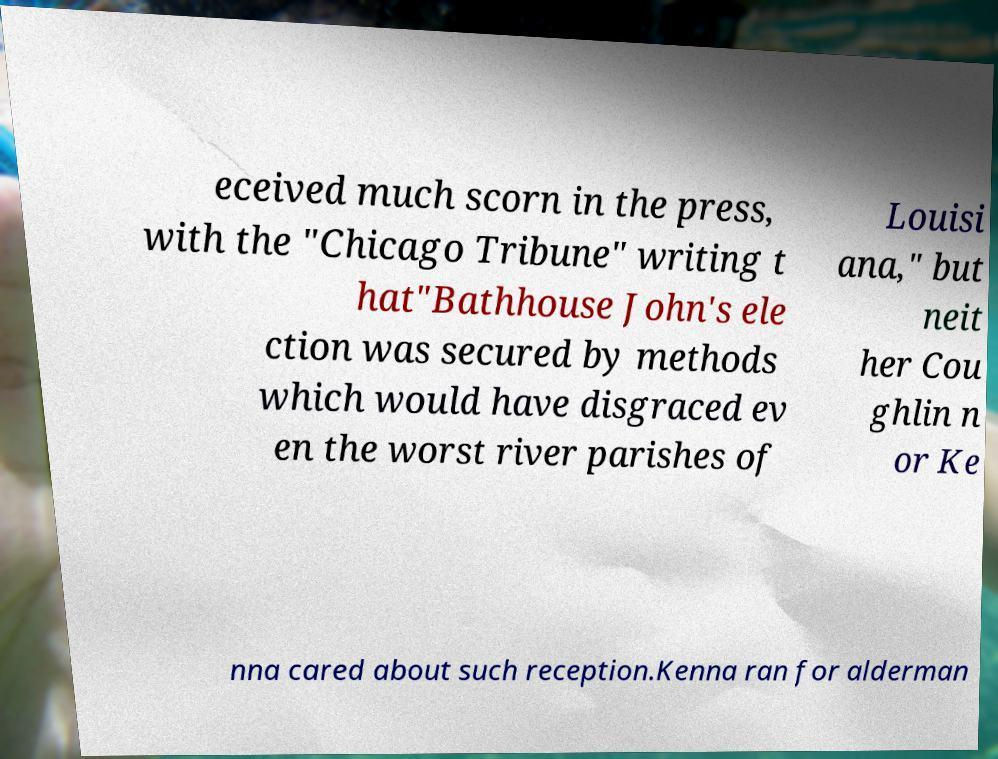What messages or text are displayed in this image? I need them in a readable, typed format. eceived much scorn in the press, with the "Chicago Tribune" writing t hat"Bathhouse John's ele ction was secured by methods which would have disgraced ev en the worst river parishes of Louisi ana," but neit her Cou ghlin n or Ke nna cared about such reception.Kenna ran for alderman 